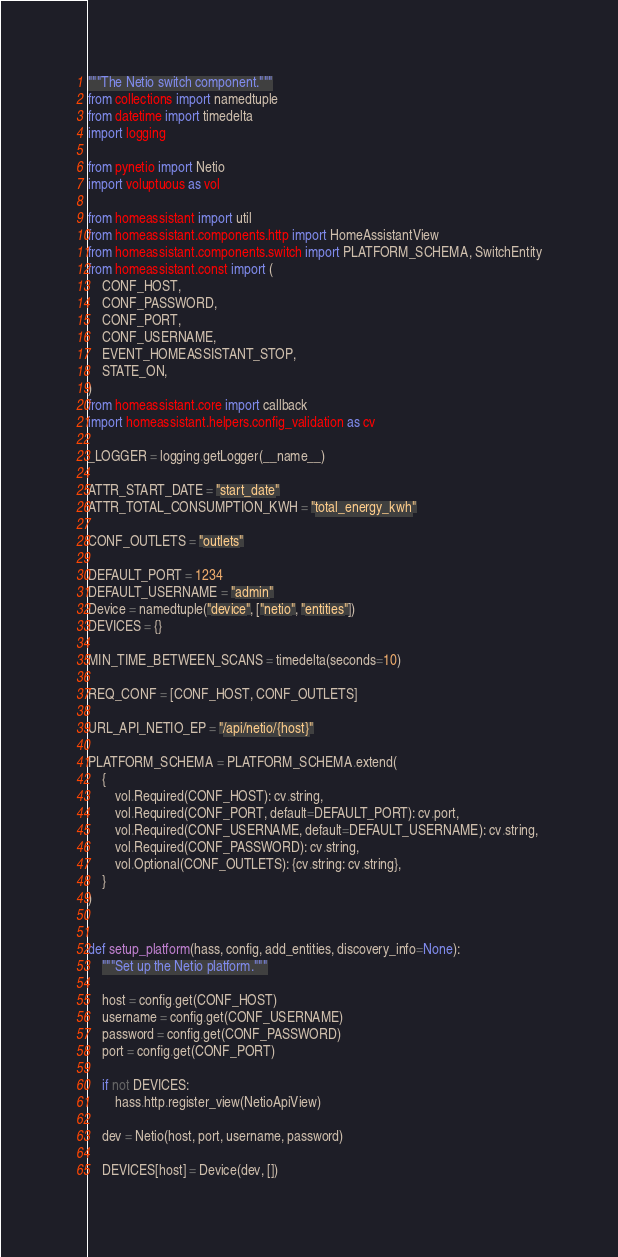<code> <loc_0><loc_0><loc_500><loc_500><_Python_>"""The Netio switch component."""
from collections import namedtuple
from datetime import timedelta
import logging

from pynetio import Netio
import voluptuous as vol

from homeassistant import util
from homeassistant.components.http import HomeAssistantView
from homeassistant.components.switch import PLATFORM_SCHEMA, SwitchEntity
from homeassistant.const import (
    CONF_HOST,
    CONF_PASSWORD,
    CONF_PORT,
    CONF_USERNAME,
    EVENT_HOMEASSISTANT_STOP,
    STATE_ON,
)
from homeassistant.core import callback
import homeassistant.helpers.config_validation as cv

_LOGGER = logging.getLogger(__name__)

ATTR_START_DATE = "start_date"
ATTR_TOTAL_CONSUMPTION_KWH = "total_energy_kwh"

CONF_OUTLETS = "outlets"

DEFAULT_PORT = 1234
DEFAULT_USERNAME = "admin"
Device = namedtuple("device", ["netio", "entities"])
DEVICES = {}

MIN_TIME_BETWEEN_SCANS = timedelta(seconds=10)

REQ_CONF = [CONF_HOST, CONF_OUTLETS]

URL_API_NETIO_EP = "/api/netio/{host}"

PLATFORM_SCHEMA = PLATFORM_SCHEMA.extend(
    {
        vol.Required(CONF_HOST): cv.string,
        vol.Required(CONF_PORT, default=DEFAULT_PORT): cv.port,
        vol.Required(CONF_USERNAME, default=DEFAULT_USERNAME): cv.string,
        vol.Required(CONF_PASSWORD): cv.string,
        vol.Optional(CONF_OUTLETS): {cv.string: cv.string},
    }
)


def setup_platform(hass, config, add_entities, discovery_info=None):
    """Set up the Netio platform."""

    host = config.get(CONF_HOST)
    username = config.get(CONF_USERNAME)
    password = config.get(CONF_PASSWORD)
    port = config.get(CONF_PORT)

    if not DEVICES:
        hass.http.register_view(NetioApiView)

    dev = Netio(host, port, username, password)

    DEVICES[host] = Device(dev, [])
</code> 